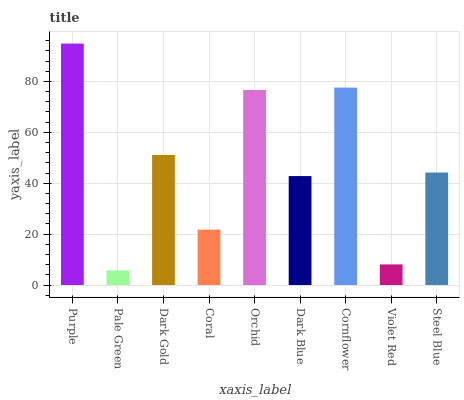Is Pale Green the minimum?
Answer yes or no. Yes. Is Purple the maximum?
Answer yes or no. Yes. Is Dark Gold the minimum?
Answer yes or no. No. Is Dark Gold the maximum?
Answer yes or no. No. Is Dark Gold greater than Pale Green?
Answer yes or no. Yes. Is Pale Green less than Dark Gold?
Answer yes or no. Yes. Is Pale Green greater than Dark Gold?
Answer yes or no. No. Is Dark Gold less than Pale Green?
Answer yes or no. No. Is Steel Blue the high median?
Answer yes or no. Yes. Is Steel Blue the low median?
Answer yes or no. Yes. Is Coral the high median?
Answer yes or no. No. Is Cornflower the low median?
Answer yes or no. No. 